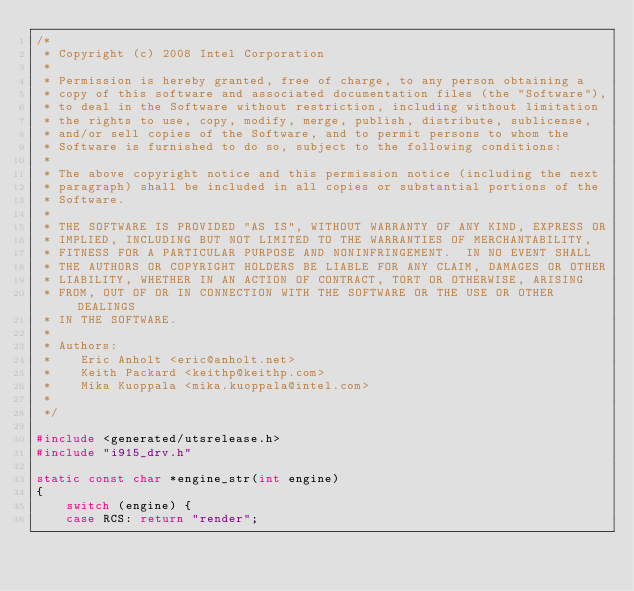Convert code to text. <code><loc_0><loc_0><loc_500><loc_500><_C_>/*
 * Copyright (c) 2008 Intel Corporation
 *
 * Permission is hereby granted, free of charge, to any person obtaining a
 * copy of this software and associated documentation files (the "Software"),
 * to deal in the Software without restriction, including without limitation
 * the rights to use, copy, modify, merge, publish, distribute, sublicense,
 * and/or sell copies of the Software, and to permit persons to whom the
 * Software is furnished to do so, subject to the following conditions:
 *
 * The above copyright notice and this permission notice (including the next
 * paragraph) shall be included in all copies or substantial portions of the
 * Software.
 *
 * THE SOFTWARE IS PROVIDED "AS IS", WITHOUT WARRANTY OF ANY KIND, EXPRESS OR
 * IMPLIED, INCLUDING BUT NOT LIMITED TO THE WARRANTIES OF MERCHANTABILITY,
 * FITNESS FOR A PARTICULAR PURPOSE AND NONINFRINGEMENT.  IN NO EVENT SHALL
 * THE AUTHORS OR COPYRIGHT HOLDERS BE LIABLE FOR ANY CLAIM, DAMAGES OR OTHER
 * LIABILITY, WHETHER IN AN ACTION OF CONTRACT, TORT OR OTHERWISE, ARISING
 * FROM, OUT OF OR IN CONNECTION WITH THE SOFTWARE OR THE USE OR OTHER DEALINGS
 * IN THE SOFTWARE.
 *
 * Authors:
 *    Eric Anholt <eric@anholt.net>
 *    Keith Packard <keithp@keithp.com>
 *    Mika Kuoppala <mika.kuoppala@intel.com>
 *
 */

#include <generated/utsrelease.h>
#include "i915_drv.h"

static const char *engine_str(int engine)
{
	switch (engine) {
	case RCS: return "render";</code> 